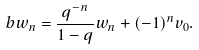<formula> <loc_0><loc_0><loc_500><loc_500>b w _ { n } = \frac { q ^ { - n } } { 1 - q } w _ { n } + ( - 1 ) ^ { n } v _ { 0 } .</formula> 